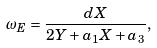<formula> <loc_0><loc_0><loc_500><loc_500>\omega _ { E } = \frac { d X } { 2 Y + a _ { 1 } X + a _ { 3 } } ,</formula> 